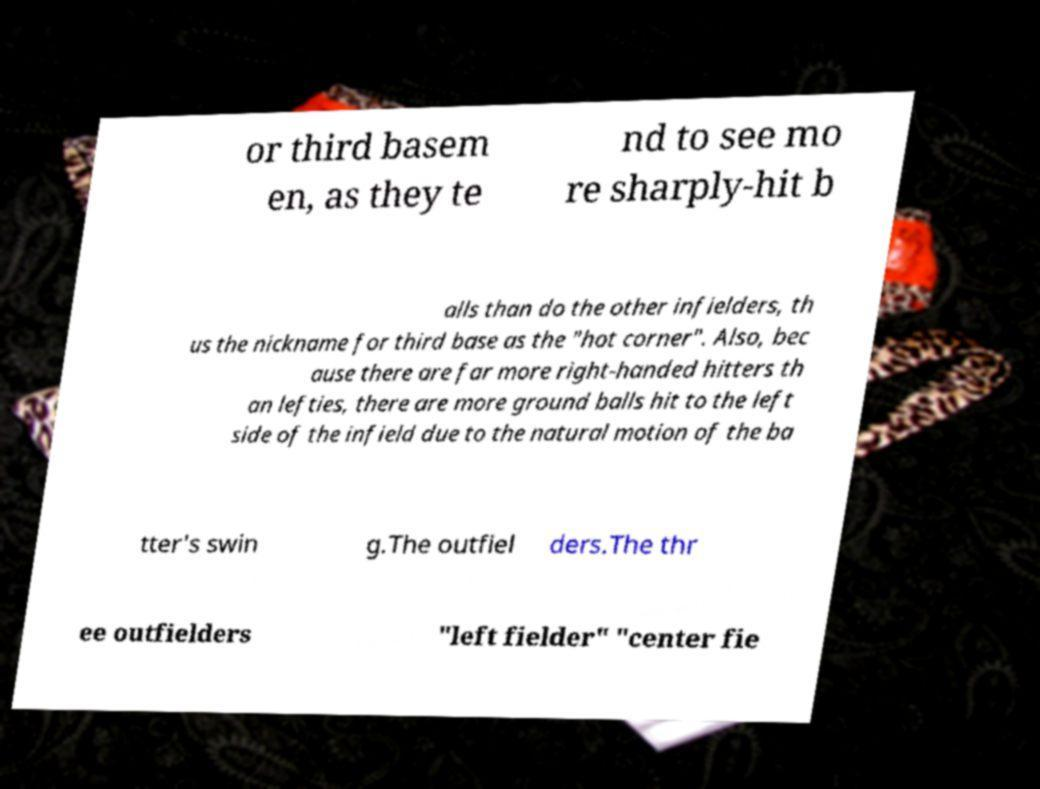Can you read and provide the text displayed in the image?This photo seems to have some interesting text. Can you extract and type it out for me? or third basem en, as they te nd to see mo re sharply-hit b alls than do the other infielders, th us the nickname for third base as the "hot corner". Also, bec ause there are far more right-handed hitters th an lefties, there are more ground balls hit to the left side of the infield due to the natural motion of the ba tter's swin g.The outfiel ders.The thr ee outfielders "left fielder" "center fie 